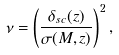<formula> <loc_0><loc_0><loc_500><loc_500>\nu = \left ( \frac { \delta _ { s c } ( z ) } { \sigma ( M , z ) } \right ) ^ { 2 } ,</formula> 